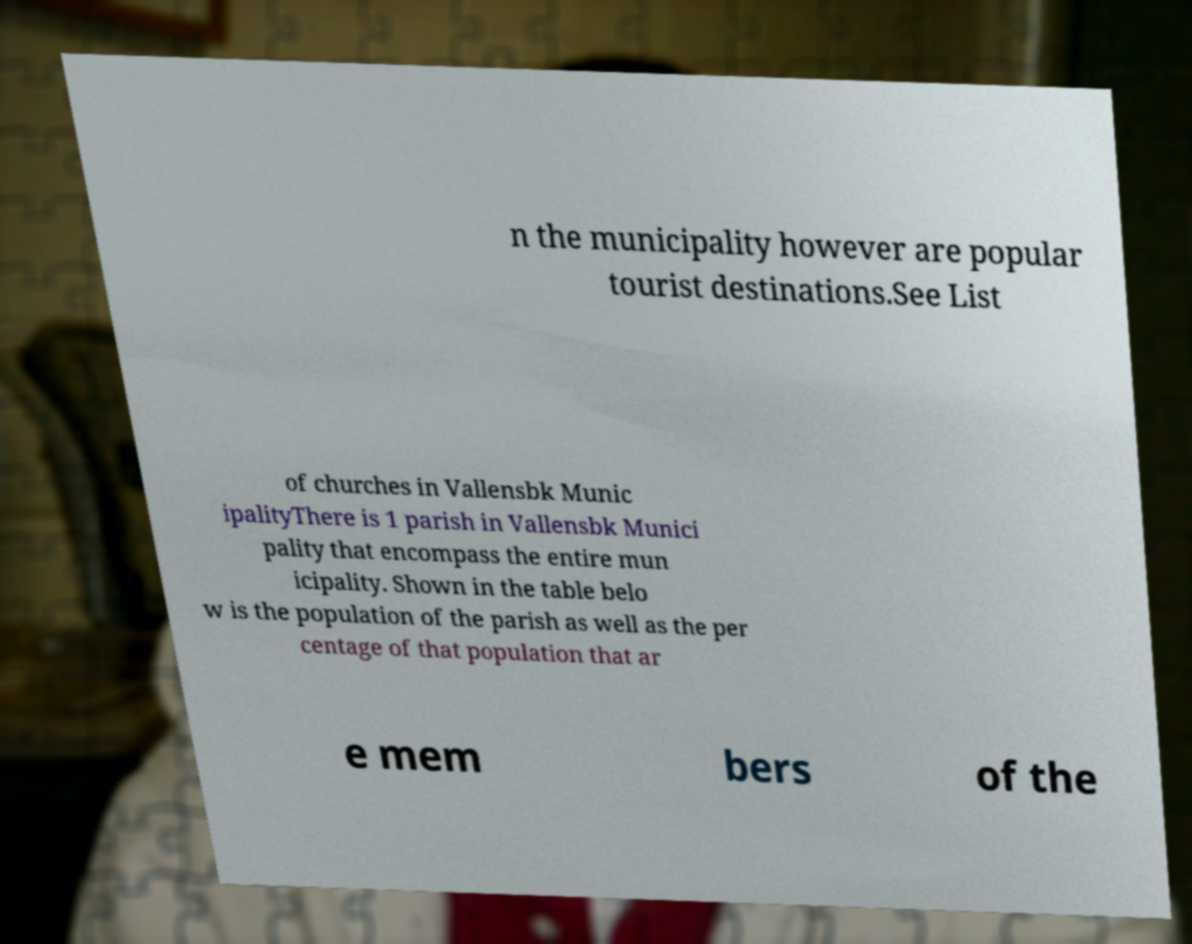Can you read and provide the text displayed in the image?This photo seems to have some interesting text. Can you extract and type it out for me? n the municipality however are popular tourist destinations.See List of churches in Vallensbk Munic ipalityThere is 1 parish in Vallensbk Munici pality that encompass the entire mun icipality. Shown in the table belo w is the population of the parish as well as the per centage of that population that ar e mem bers of the 